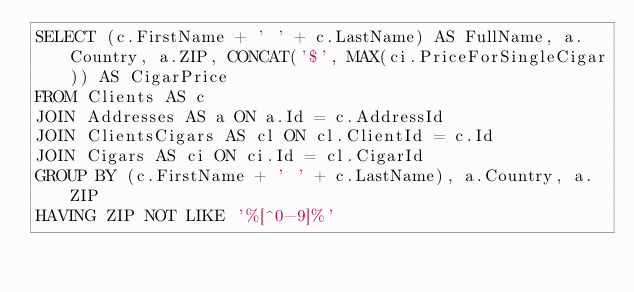<code> <loc_0><loc_0><loc_500><loc_500><_SQL_>SELECT (c.FirstName + ' ' + c.LastName) AS FullName, a.Country, a.ZIP, CONCAT('$', MAX(ci.PriceForSingleCigar)) AS CigarPrice
FROM Clients AS c
JOIN Addresses AS a ON a.Id = c.AddressId
JOIN ClientsCigars AS cl ON cl.ClientId = c.Id
JOIN Cigars AS ci ON ci.Id = cl.CigarId
GROUP BY (c.FirstName + ' ' + c.LastName), a.Country, a.ZIP
HAVING ZIP NOT LIKE '%[^0-9]%' </code> 